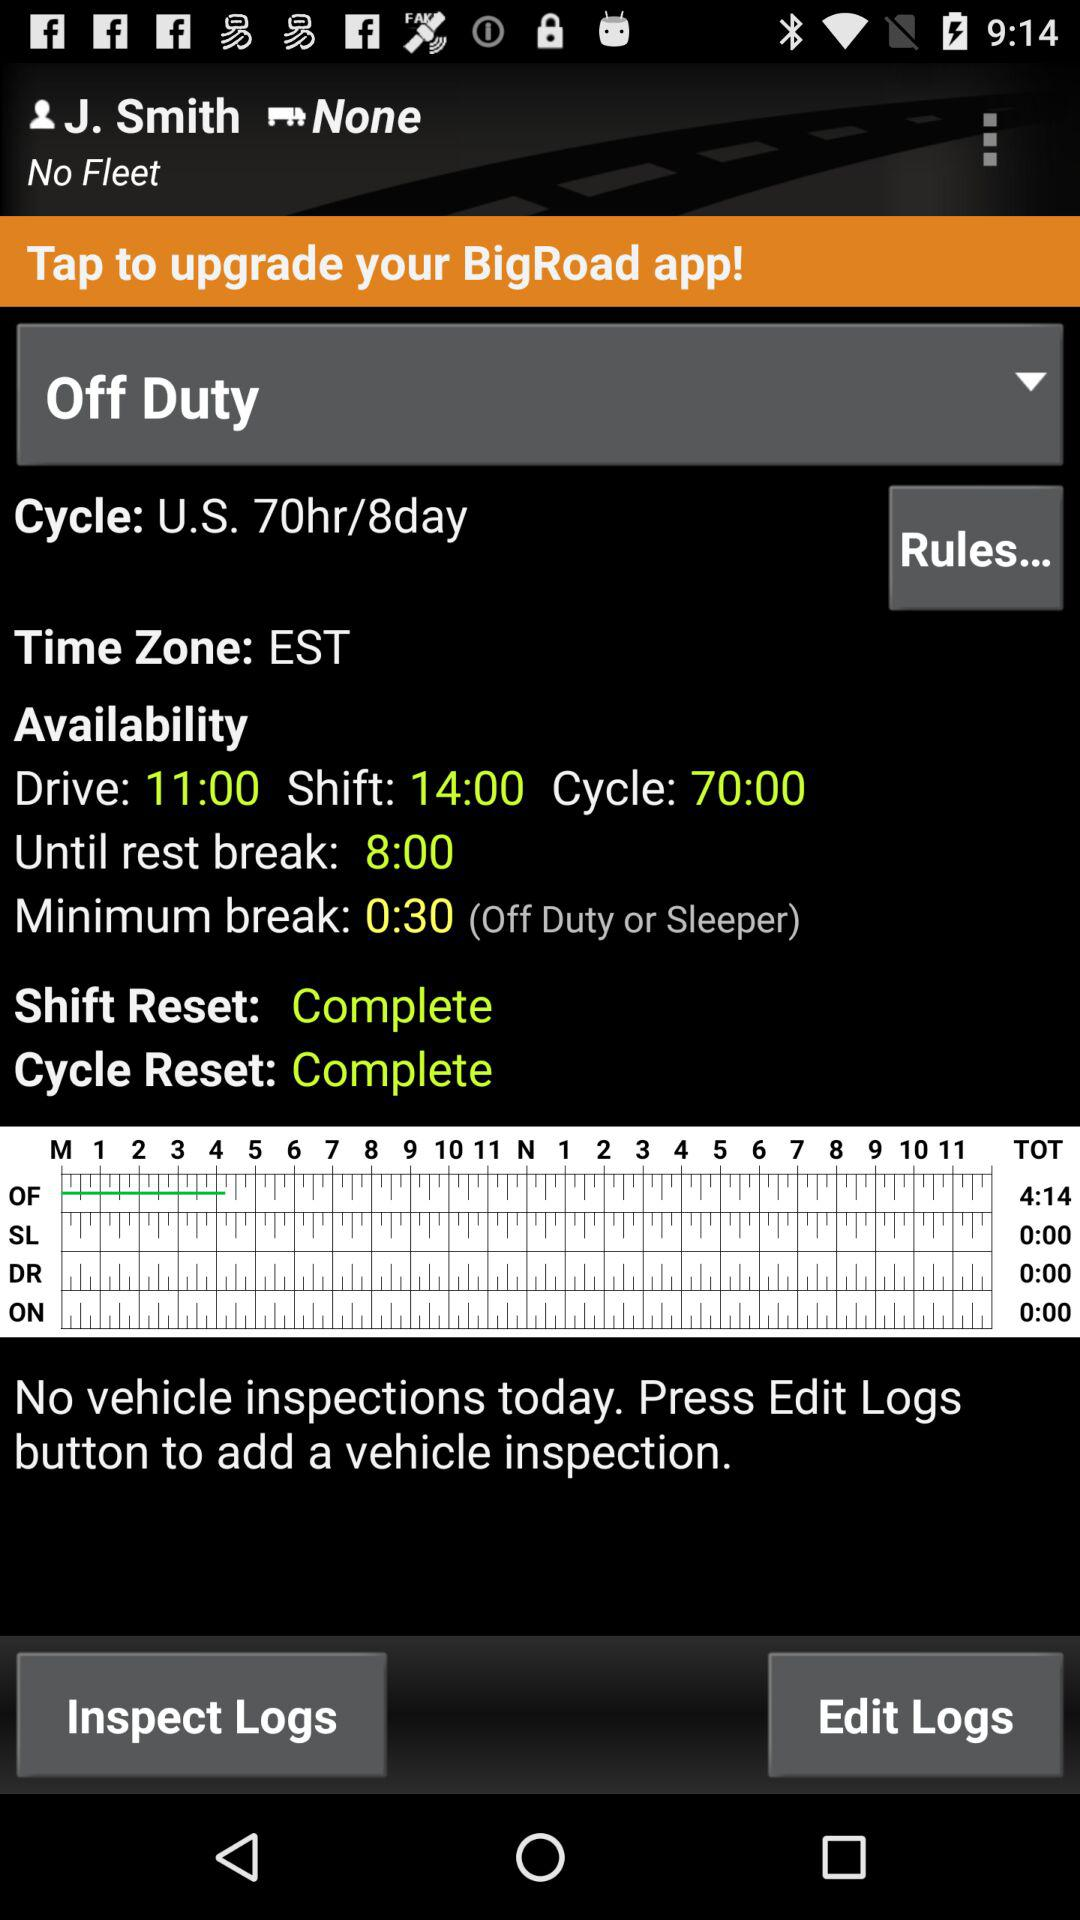What is the status of the "Shift Reset"? The status of the "Shift Reset" is "Complete". 